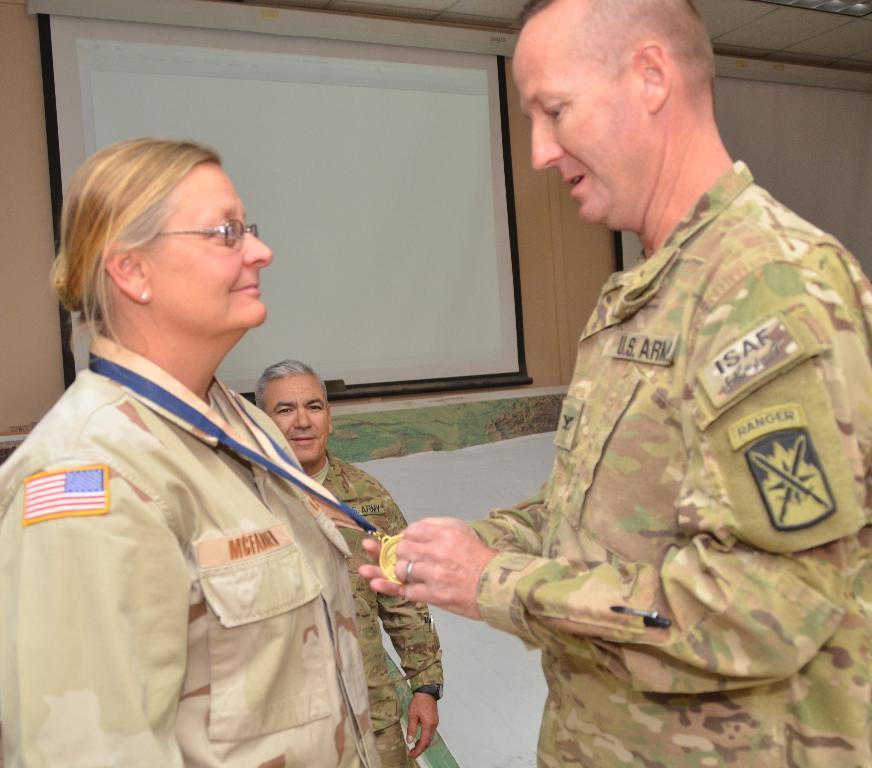Describe this image in one or two sentences. In this picture we can see three people and a woman wore a medal. In the background we can see the wall, ceiling and screens. 